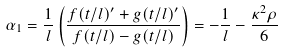Convert formula to latex. <formula><loc_0><loc_0><loc_500><loc_500>\alpha _ { 1 } = \frac { 1 } { l } \left ( \frac { f ( t / l ) ^ { \prime } + g ( t / l ) ^ { \prime } } { f ( t / l ) - g ( t / l ) } \right ) = - \frac { 1 } { l } - \frac { \kappa ^ { 2 } \rho } { 6 }</formula> 